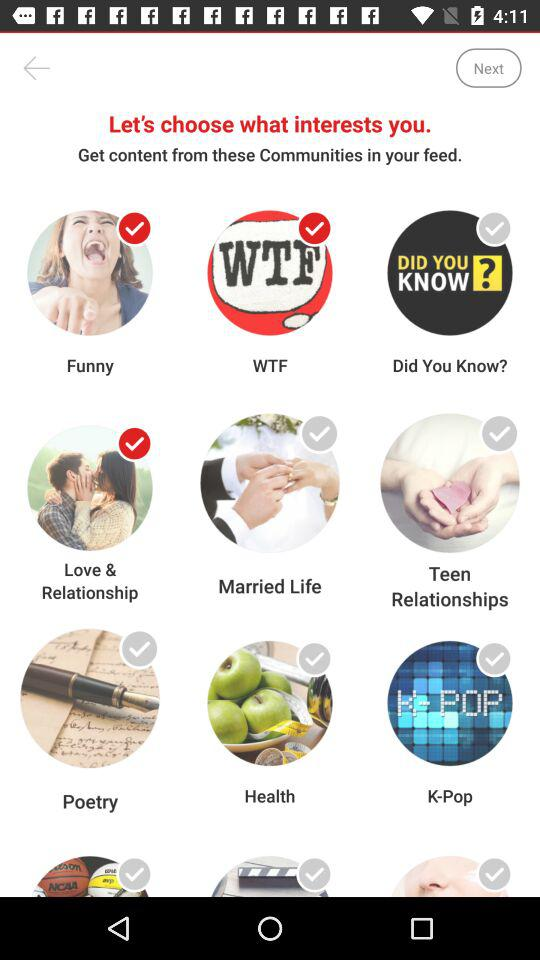What are the selected interests? The selected interests are "Funny", "WTF" and "Love & Relationship". 